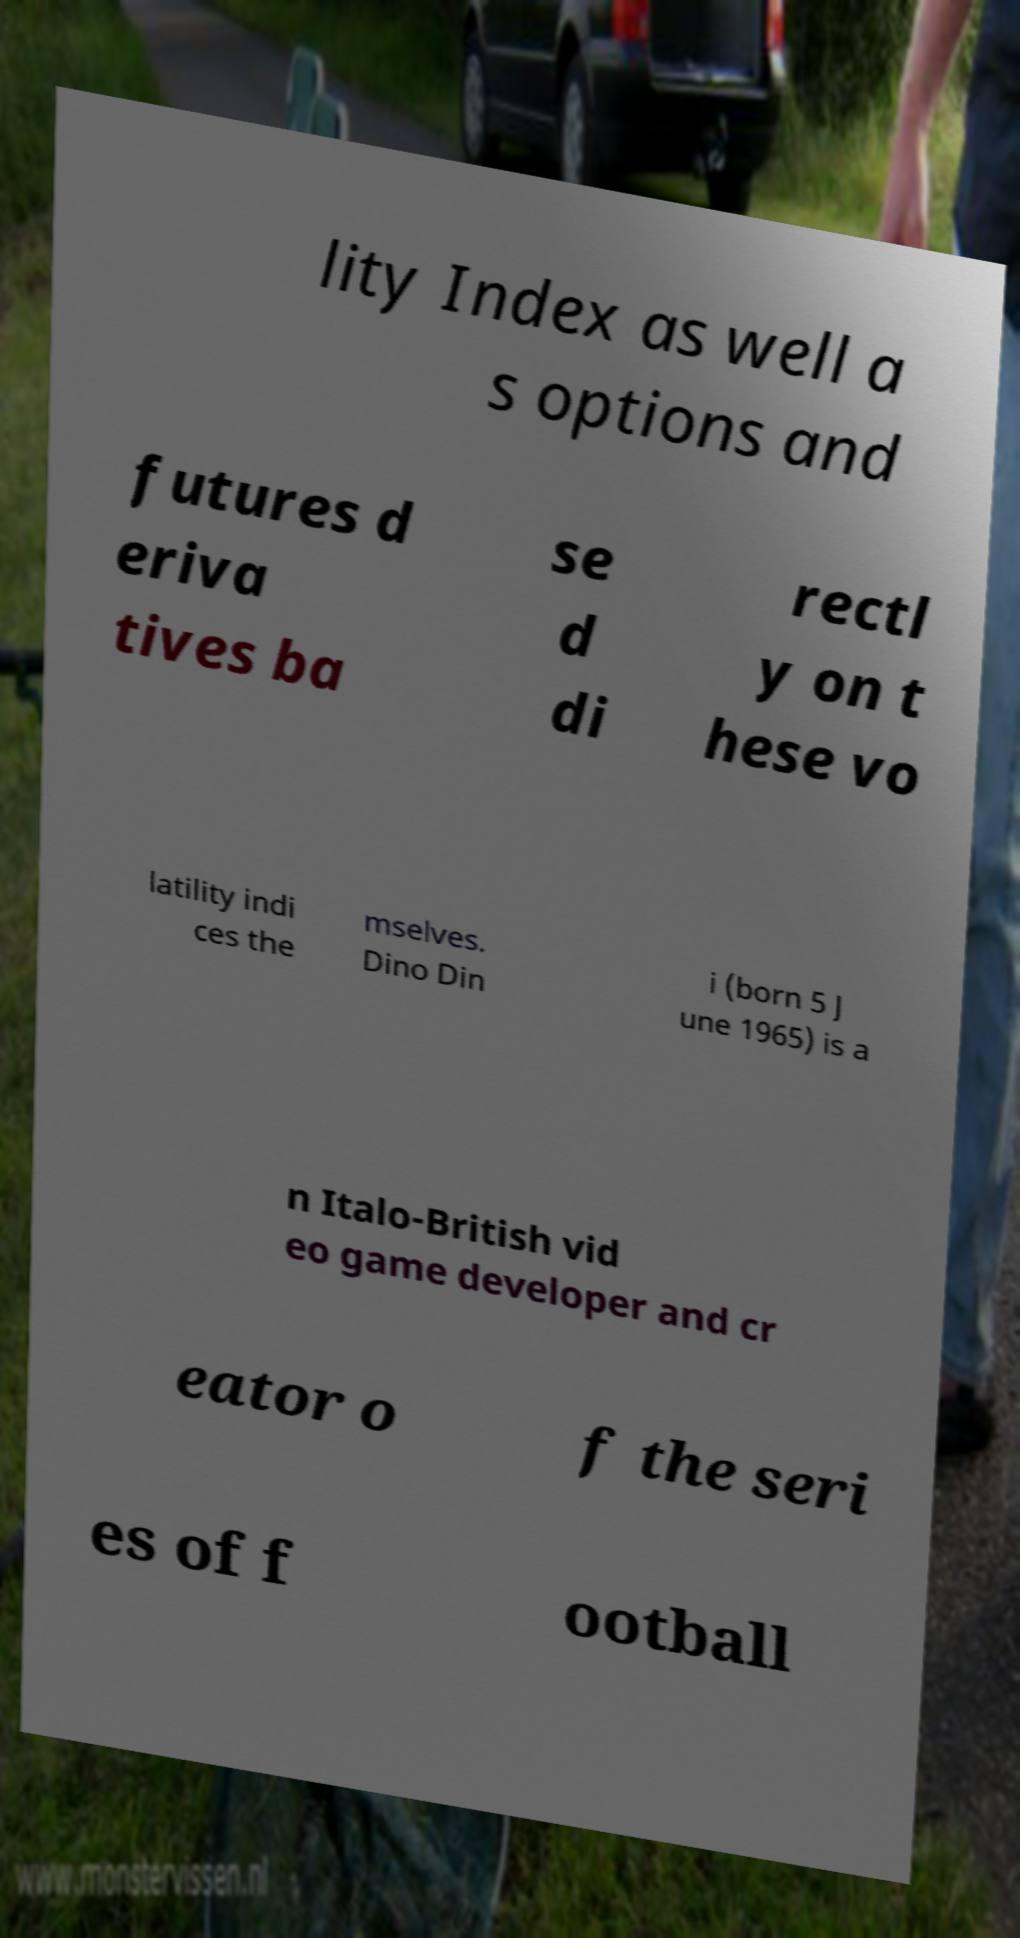There's text embedded in this image that I need extracted. Can you transcribe it verbatim? lity Index as well a s options and futures d eriva tives ba se d di rectl y on t hese vo latility indi ces the mselves. Dino Din i (born 5 J une 1965) is a n Italo-British vid eo game developer and cr eator o f the seri es of f ootball 